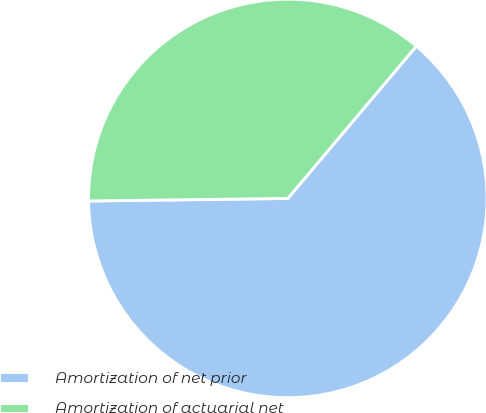Convert chart. <chart><loc_0><loc_0><loc_500><loc_500><pie_chart><fcel>Amortization of net prior<fcel>Amortization of actuarial net<nl><fcel>63.64%<fcel>36.36%<nl></chart> 